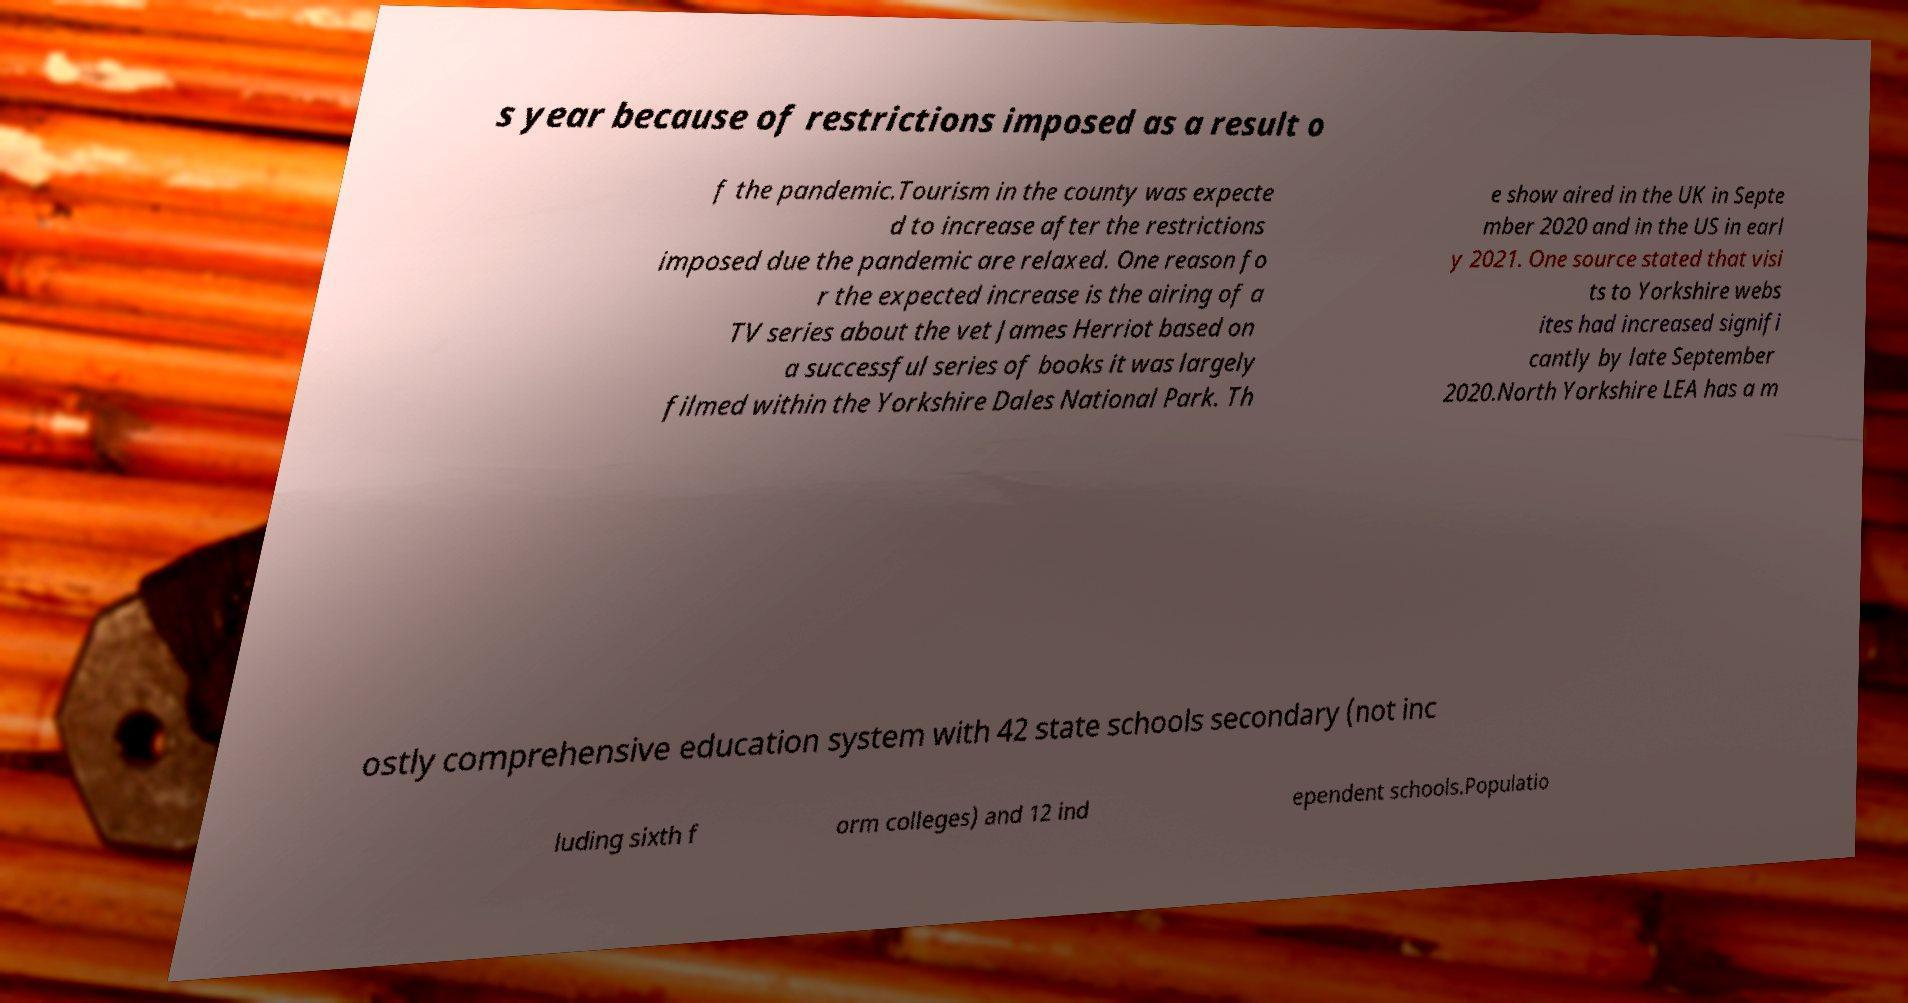Can you read and provide the text displayed in the image?This photo seems to have some interesting text. Can you extract and type it out for me? s year because of restrictions imposed as a result o f the pandemic.Tourism in the county was expecte d to increase after the restrictions imposed due the pandemic are relaxed. One reason fo r the expected increase is the airing of a TV series about the vet James Herriot based on a successful series of books it was largely filmed within the Yorkshire Dales National Park. Th e show aired in the UK in Septe mber 2020 and in the US in earl y 2021. One source stated that visi ts to Yorkshire webs ites had increased signifi cantly by late September 2020.North Yorkshire LEA has a m ostly comprehensive education system with 42 state schools secondary (not inc luding sixth f orm colleges) and 12 ind ependent schools.Populatio 